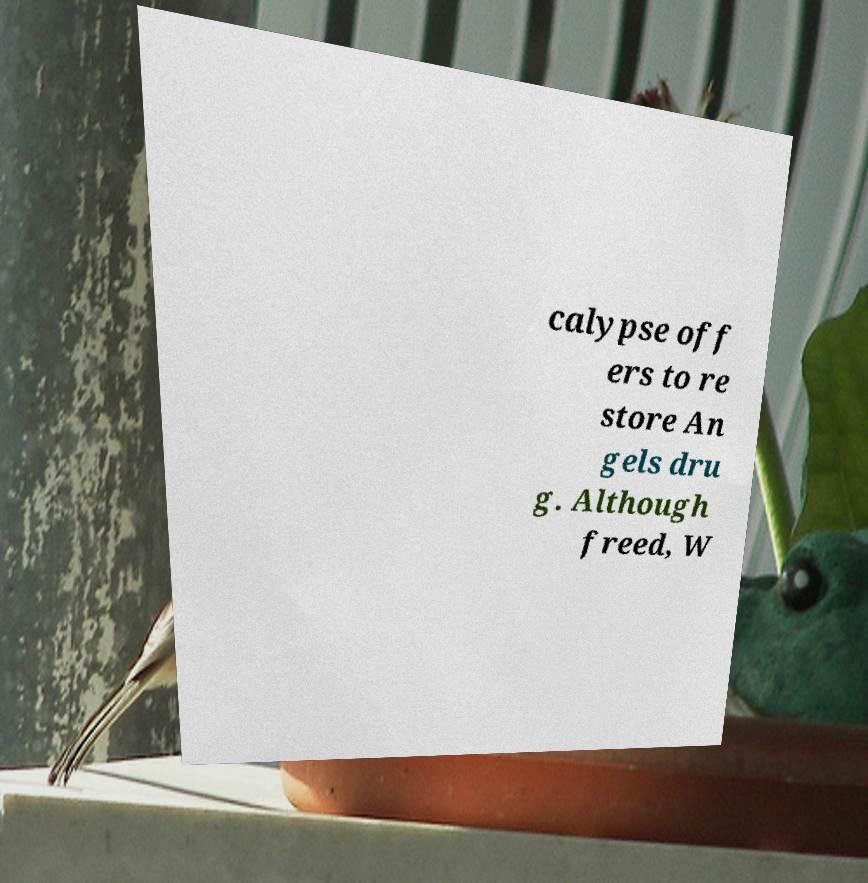There's text embedded in this image that I need extracted. Can you transcribe it verbatim? calypse off ers to re store An gels dru g. Although freed, W 